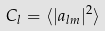Convert formula to latex. <formula><loc_0><loc_0><loc_500><loc_500>C _ { l } = \langle | a _ { l m } | ^ { 2 } \rangle</formula> 